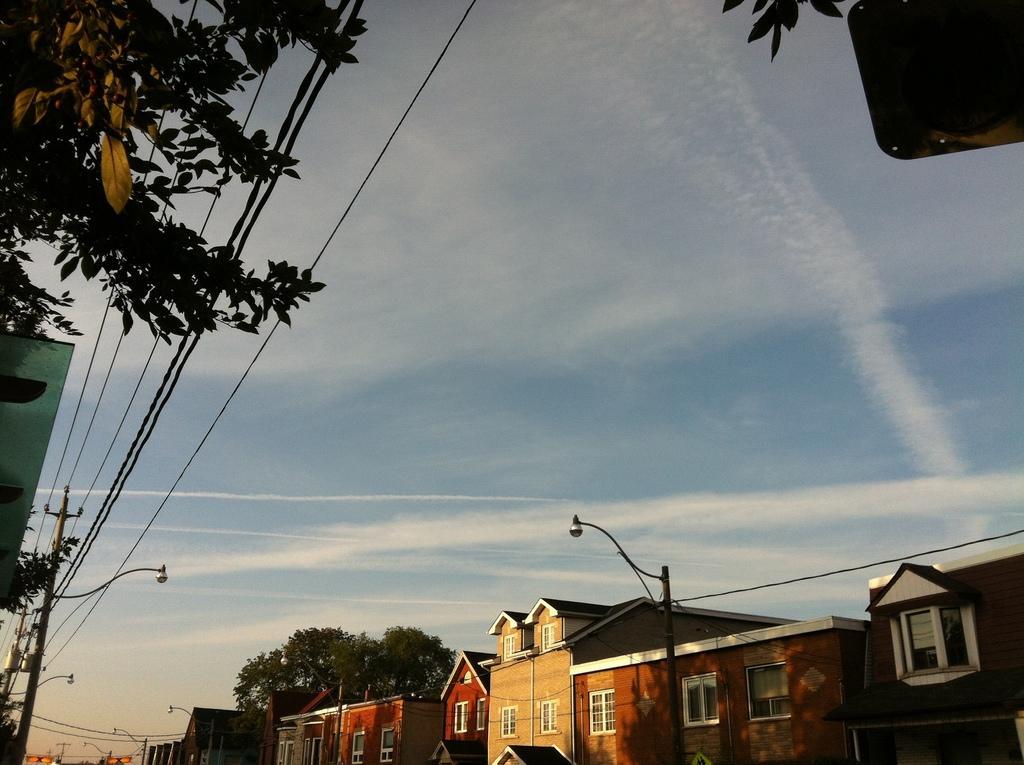Could you give a brief overview of what you see in this image? In this image I can see buildings, trees, poles which has wires and street lights. In the background I can see the sky. 